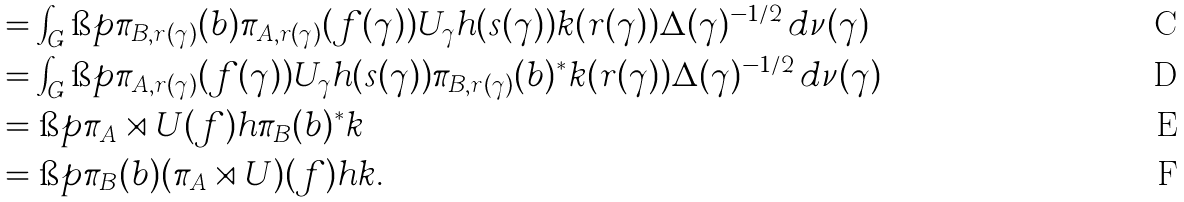<formula> <loc_0><loc_0><loc_500><loc_500>& = \int _ { G } \i p { \pi _ { B , r ( \gamma ) } ( b ) \pi _ { A , r ( \gamma ) } ( f ( \gamma ) ) U _ { \gamma } h ( s ( \gamma ) ) } { k ( r ( \gamma ) ) } \Delta ( \gamma ) ^ { - 1 / 2 } \, d \nu ( \gamma ) \\ & = \int _ { G } \i p { \pi _ { A , r ( \gamma ) } ( f ( \gamma ) ) U _ { \gamma } h ( s ( \gamma ) ) } { \pi _ { B , r ( \gamma ) } ( b ) ^ { * } k ( r ( \gamma ) ) } \Delta ( \gamma ) ^ { - 1 / 2 } \, d \nu ( \gamma ) \\ & = \i p { \pi _ { A } \rtimes U ( f ) h } { \pi _ { B } ( b ) ^ { * } k } \\ & = \i p { \pi _ { B } ( b ) ( \pi _ { A } \rtimes U ) ( f ) h } { k } .</formula> 